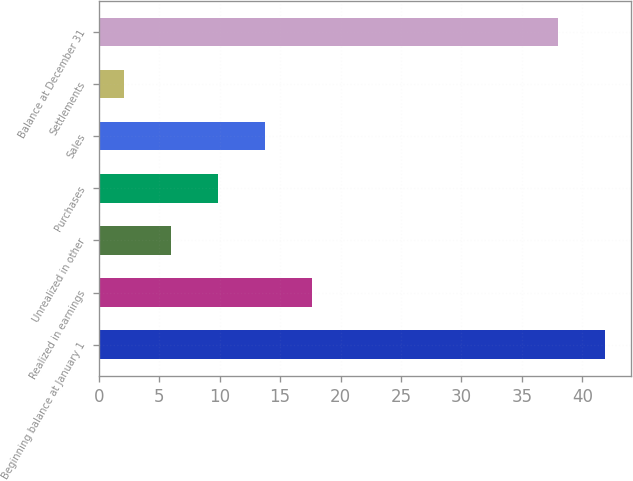Convert chart to OTSL. <chart><loc_0><loc_0><loc_500><loc_500><bar_chart><fcel>Beginning balance at January 1<fcel>Realized in earnings<fcel>Unrealized in other<fcel>Purchases<fcel>Sales<fcel>Settlements<fcel>Balance at December 31<nl><fcel>41.89<fcel>17.64<fcel>5.97<fcel>9.86<fcel>13.75<fcel>2.08<fcel>38<nl></chart> 